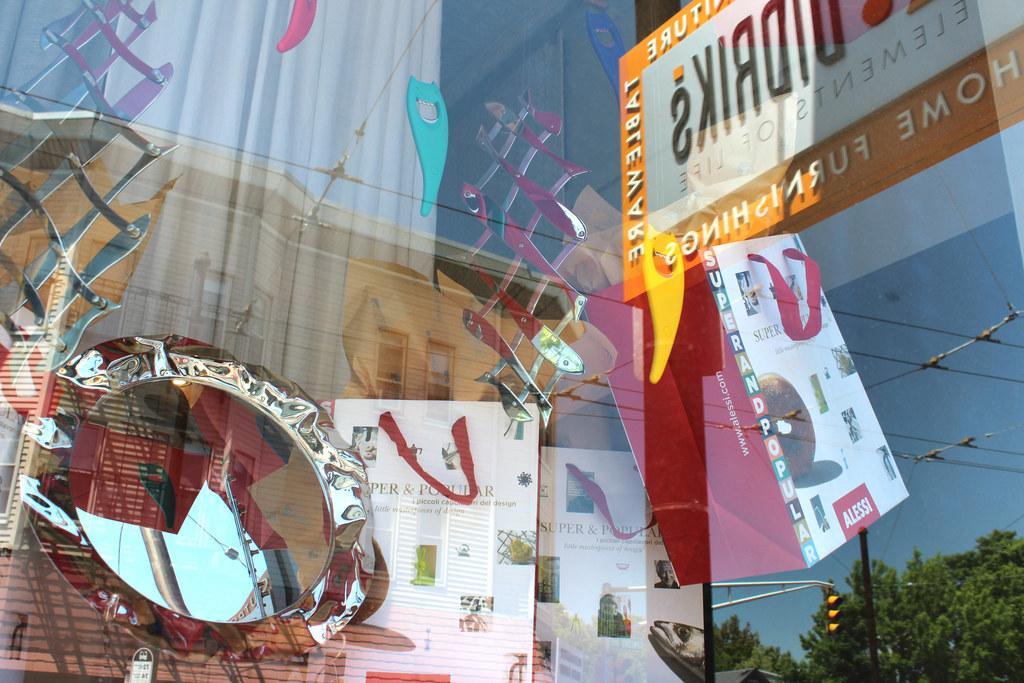Please provide a concise description of this image. In this picture we can see few bags, mirror and a curtain from the glass door, and also we can see few cables, traffic lights, trees and metal rods in the reflection. 